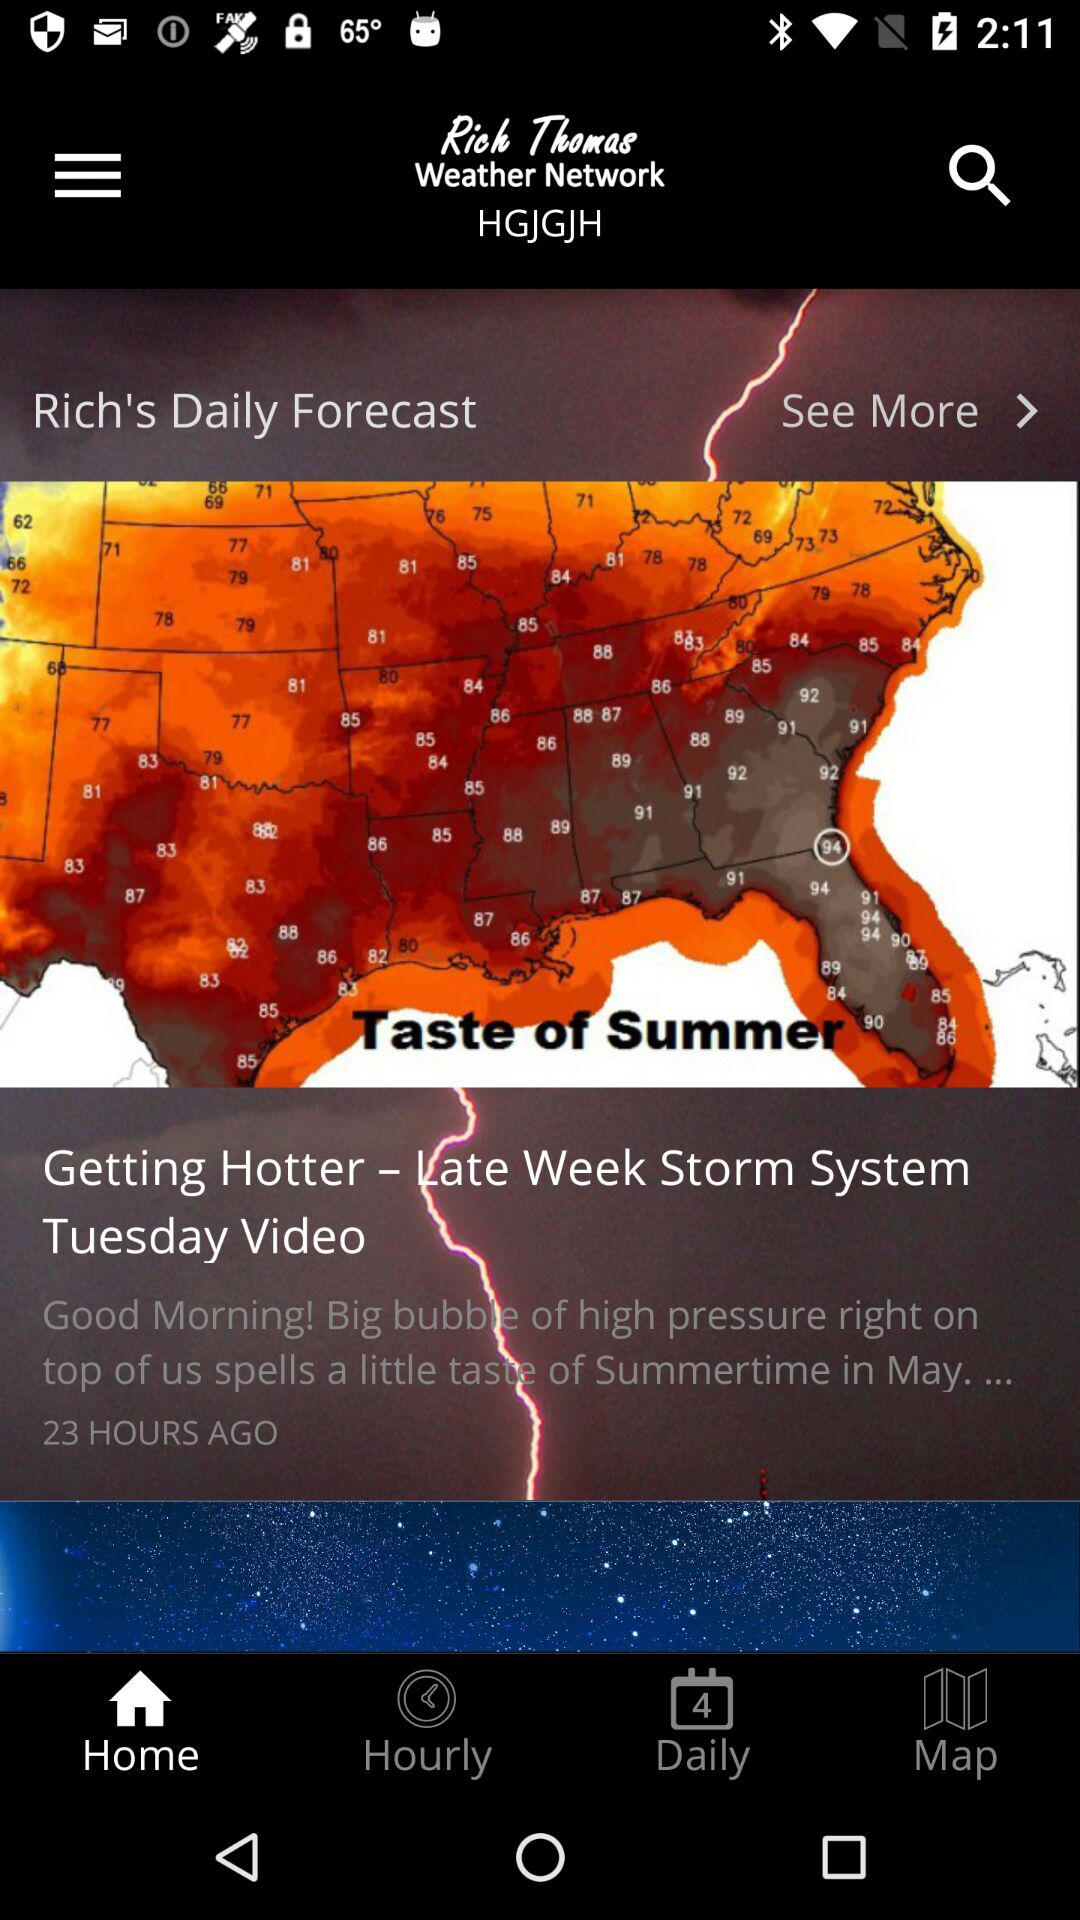How many hours have passed since the last update?
Answer the question using a single word or phrase. 23 